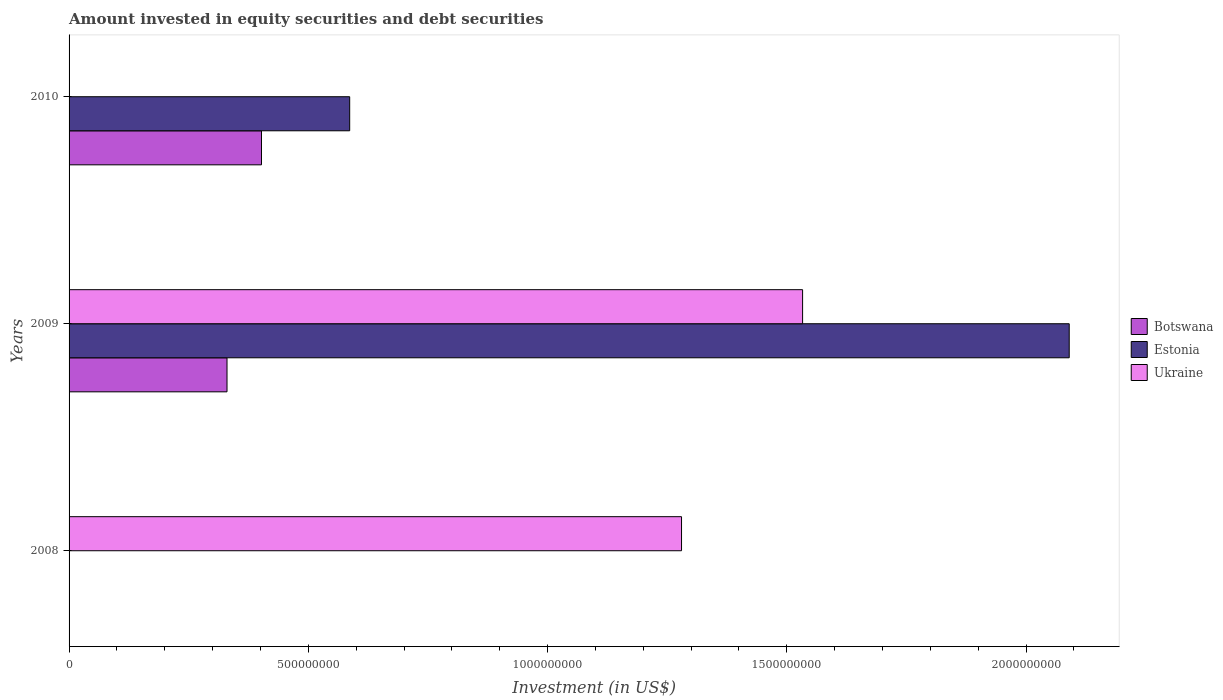How many different coloured bars are there?
Your answer should be compact. 3. How many bars are there on the 3rd tick from the bottom?
Make the answer very short. 2. What is the label of the 1st group of bars from the top?
Provide a succinct answer. 2010. Across all years, what is the maximum amount invested in equity securities and debt securities in Estonia?
Provide a short and direct response. 2.09e+09. What is the total amount invested in equity securities and debt securities in Ukraine in the graph?
Offer a terse response. 2.81e+09. What is the difference between the amount invested in equity securities and debt securities in Botswana in 2009 and that in 2010?
Provide a short and direct response. -7.21e+07. What is the average amount invested in equity securities and debt securities in Botswana per year?
Provide a short and direct response. 2.44e+08. In the year 2010, what is the difference between the amount invested in equity securities and debt securities in Botswana and amount invested in equity securities and debt securities in Estonia?
Make the answer very short. -1.84e+08. What is the ratio of the amount invested in equity securities and debt securities in Estonia in 2009 to that in 2010?
Give a very brief answer. 3.56. Is the amount invested in equity securities and debt securities in Botswana in 2009 less than that in 2010?
Your answer should be very brief. Yes. What is the difference between the highest and the lowest amount invested in equity securities and debt securities in Botswana?
Your answer should be very brief. 4.02e+08. Is the sum of the amount invested in equity securities and debt securities in Estonia in 2009 and 2010 greater than the maximum amount invested in equity securities and debt securities in Ukraine across all years?
Keep it short and to the point. Yes. How many years are there in the graph?
Keep it short and to the point. 3. Are the values on the major ticks of X-axis written in scientific E-notation?
Provide a short and direct response. No. Does the graph contain any zero values?
Give a very brief answer. Yes. Does the graph contain grids?
Your answer should be compact. No. Where does the legend appear in the graph?
Provide a succinct answer. Center right. How are the legend labels stacked?
Your answer should be compact. Vertical. What is the title of the graph?
Give a very brief answer. Amount invested in equity securities and debt securities. Does "Turkey" appear as one of the legend labels in the graph?
Offer a very short reply. No. What is the label or title of the X-axis?
Give a very brief answer. Investment (in US$). What is the Investment (in US$) of Botswana in 2008?
Ensure brevity in your answer.  0. What is the Investment (in US$) of Ukraine in 2008?
Keep it short and to the point. 1.28e+09. What is the Investment (in US$) of Botswana in 2009?
Keep it short and to the point. 3.30e+08. What is the Investment (in US$) of Estonia in 2009?
Make the answer very short. 2.09e+09. What is the Investment (in US$) in Ukraine in 2009?
Keep it short and to the point. 1.53e+09. What is the Investment (in US$) of Botswana in 2010?
Give a very brief answer. 4.02e+08. What is the Investment (in US$) of Estonia in 2010?
Provide a succinct answer. 5.86e+08. Across all years, what is the maximum Investment (in US$) in Botswana?
Make the answer very short. 4.02e+08. Across all years, what is the maximum Investment (in US$) in Estonia?
Your answer should be very brief. 2.09e+09. Across all years, what is the maximum Investment (in US$) in Ukraine?
Offer a terse response. 1.53e+09. Across all years, what is the minimum Investment (in US$) in Botswana?
Provide a short and direct response. 0. What is the total Investment (in US$) in Botswana in the graph?
Your answer should be very brief. 7.32e+08. What is the total Investment (in US$) of Estonia in the graph?
Offer a terse response. 2.68e+09. What is the total Investment (in US$) of Ukraine in the graph?
Your response must be concise. 2.81e+09. What is the difference between the Investment (in US$) in Ukraine in 2008 and that in 2009?
Your response must be concise. -2.53e+08. What is the difference between the Investment (in US$) of Botswana in 2009 and that in 2010?
Provide a succinct answer. -7.21e+07. What is the difference between the Investment (in US$) in Estonia in 2009 and that in 2010?
Provide a short and direct response. 1.50e+09. What is the difference between the Investment (in US$) of Botswana in 2009 and the Investment (in US$) of Estonia in 2010?
Give a very brief answer. -2.56e+08. What is the average Investment (in US$) in Botswana per year?
Ensure brevity in your answer.  2.44e+08. What is the average Investment (in US$) of Estonia per year?
Give a very brief answer. 8.92e+08. What is the average Investment (in US$) in Ukraine per year?
Give a very brief answer. 9.38e+08. In the year 2009, what is the difference between the Investment (in US$) of Botswana and Investment (in US$) of Estonia?
Make the answer very short. -1.76e+09. In the year 2009, what is the difference between the Investment (in US$) of Botswana and Investment (in US$) of Ukraine?
Give a very brief answer. -1.20e+09. In the year 2009, what is the difference between the Investment (in US$) in Estonia and Investment (in US$) in Ukraine?
Make the answer very short. 5.57e+08. In the year 2010, what is the difference between the Investment (in US$) of Botswana and Investment (in US$) of Estonia?
Ensure brevity in your answer.  -1.84e+08. What is the ratio of the Investment (in US$) of Ukraine in 2008 to that in 2009?
Your response must be concise. 0.83. What is the ratio of the Investment (in US$) of Botswana in 2009 to that in 2010?
Ensure brevity in your answer.  0.82. What is the ratio of the Investment (in US$) in Estonia in 2009 to that in 2010?
Provide a succinct answer. 3.56. What is the difference between the highest and the lowest Investment (in US$) in Botswana?
Make the answer very short. 4.02e+08. What is the difference between the highest and the lowest Investment (in US$) in Estonia?
Your answer should be very brief. 2.09e+09. What is the difference between the highest and the lowest Investment (in US$) of Ukraine?
Your response must be concise. 1.53e+09. 